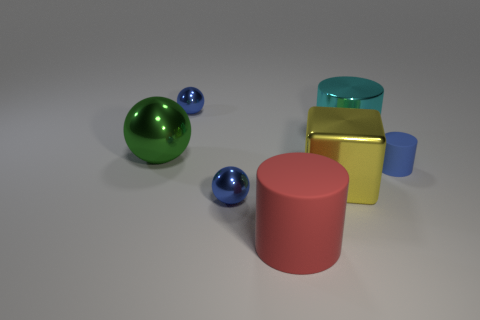How many things are either yellow metallic cubes to the left of the cyan shiny thing or blue metal blocks?
Keep it short and to the point. 1. Does the tiny object that is behind the big green sphere have the same color as the shiny cylinder?
Keep it short and to the point. No. There is a metallic object left of the small shiny sphere behind the large yellow block; what is its shape?
Your answer should be compact. Sphere. Is the number of big things left of the yellow metallic thing less than the number of large metallic objects behind the blue rubber object?
Provide a short and direct response. No. What is the size of the red rubber object that is the same shape as the blue matte object?
Give a very brief answer. Large. Is there any other thing that has the same size as the cyan shiny object?
Provide a short and direct response. Yes. How many objects are metallic balls that are on the left side of the cyan metal object or blue things to the right of the big cube?
Provide a short and direct response. 4. Is the green object the same size as the blue rubber thing?
Provide a short and direct response. No. Are there more cyan matte spheres than yellow metal things?
Your response must be concise. No. What number of other objects are there of the same color as the tiny rubber object?
Provide a short and direct response. 2. 